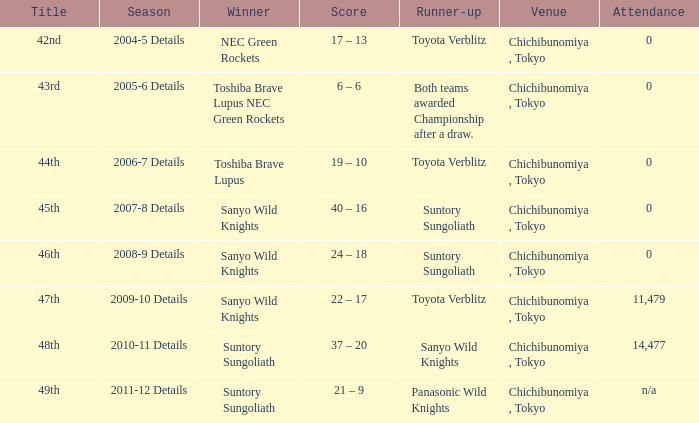What is the number of attendees when the team in second place was suntory sungoliath, and a 46th tournament? 0.0. 